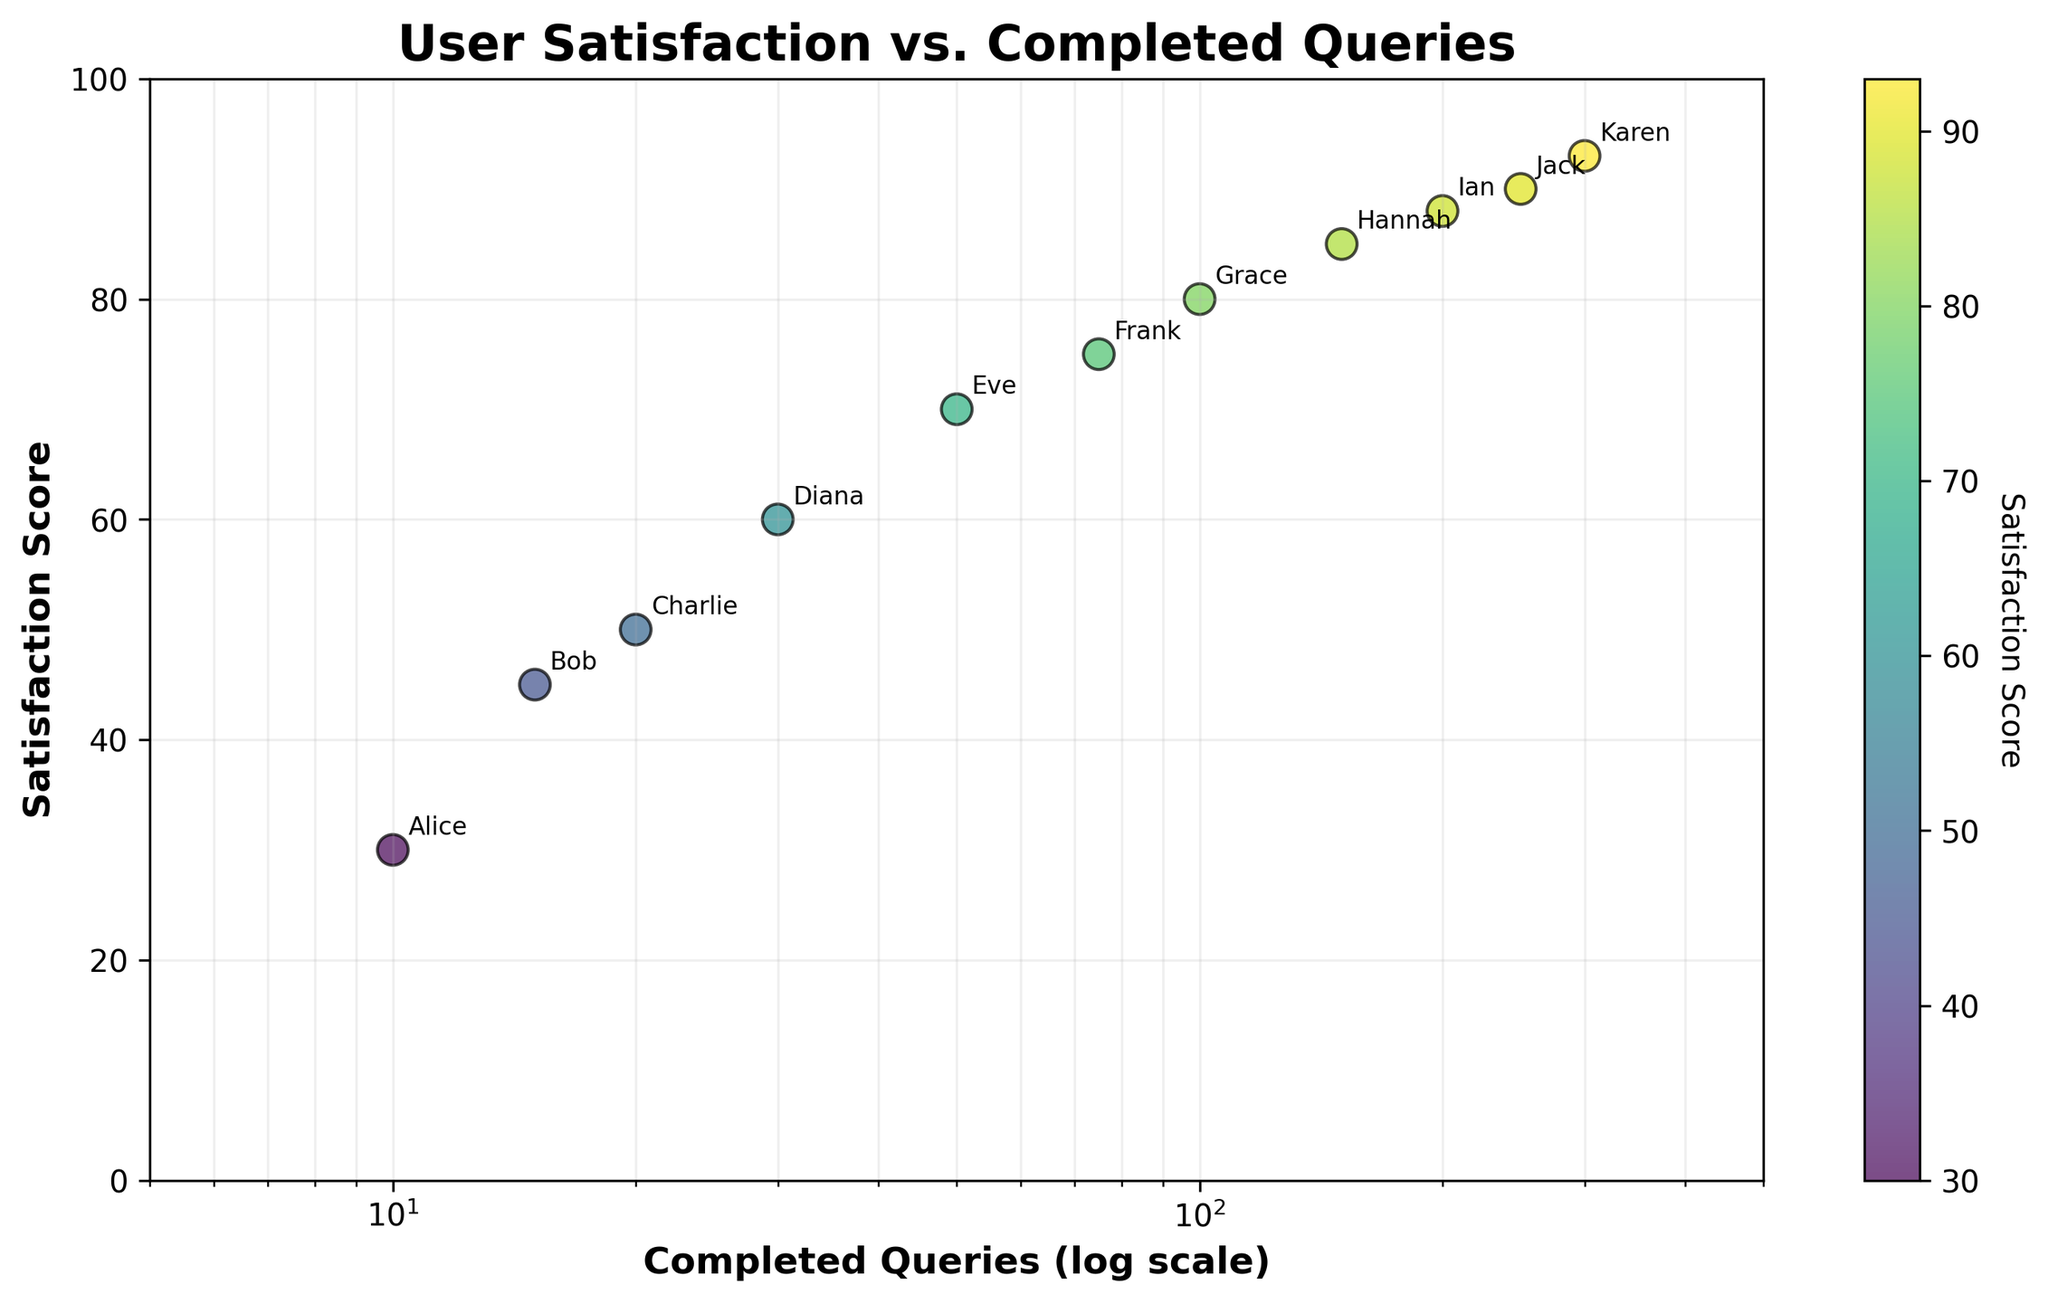What's the title of the figure? The title is usually displayed at the top of the chart. In this figure, the title is clearly written.
Answer: User Satisfaction vs. Completed Queries What is the x-axis label? The x-axis label is typically found below the horizontal axis on the chart. Here, it describes the log-scaled number of completed queries.
Answer: Completed Queries (log scale) How many users have their data points displayed in the figure? Each user has a labeled data point on the scatter plot. By counting the annotations, we can determine the number of users.
Answer: 11 What are the x and y values for the user 'Grace'? Locate the annotation for 'Grace' on the scatter plot and read its corresponding x and y values.
Answer: 100, 80 Which user has the highest satisfaction score? Identify the data point with the highest y-value on the scatter plot and check the associated annotation for the user.
Answer: Karen How does the satisfaction score change as the number of completed queries increases from 10 to about 300? Observe the trend of data points from lower to higher x-values on the log scale. The satisfaction score generally increases.
Answer: It increases How many users have completed more than 100 queries? Identify data points with x-values greater than 100, considering the log scale, and count the corresponding users.
Answer: 4 Is there a user with a satisfaction score of 88, and if so, who is it? Look for the y-value of 88 on the scatter plot and check the annotation for the corresponding data point.
Answer: Ian Compare the satisfaction scores of Alice and Bob. Who is more satisfied? Locate the annotations for Alice and Bob and compare their y-values (satisfaction scores).
Answer: Bob By how much does Hannah's satisfaction score differ from Karen's? Subtract Hannah's satisfaction score from Karen's satisfaction score.
Answer: 8 